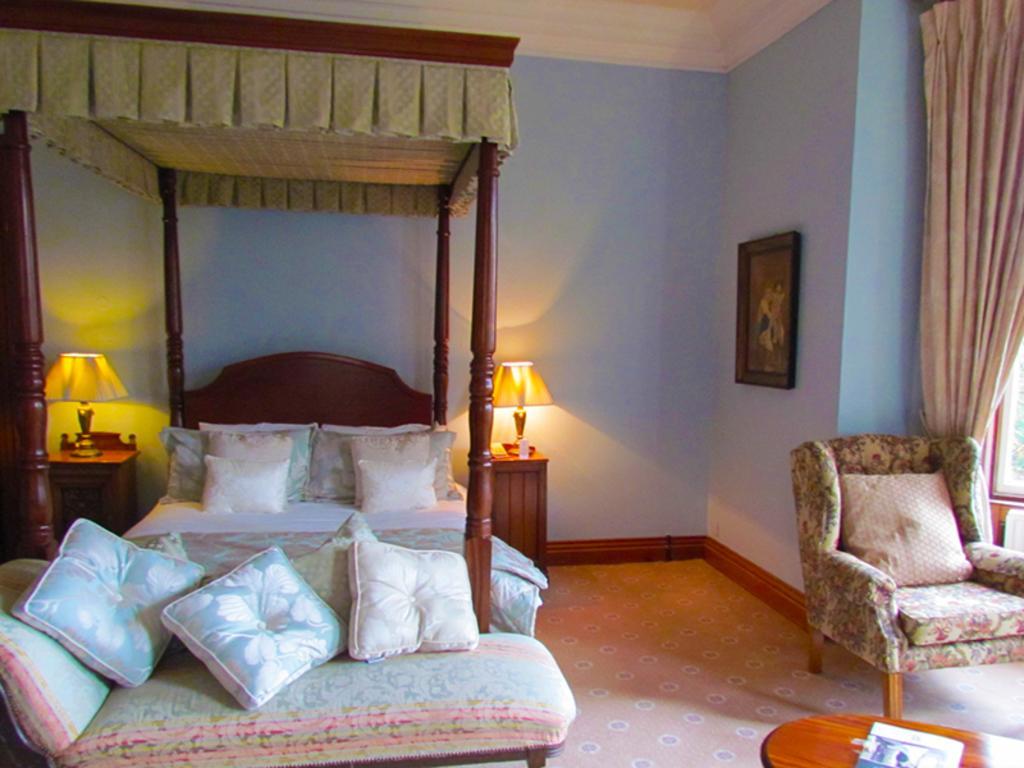Please provide a concise description of this image. In this image I can see a bed room contains bed,couch,pillows,lamp,chair,table,curtain and the frame attached to the wall. 